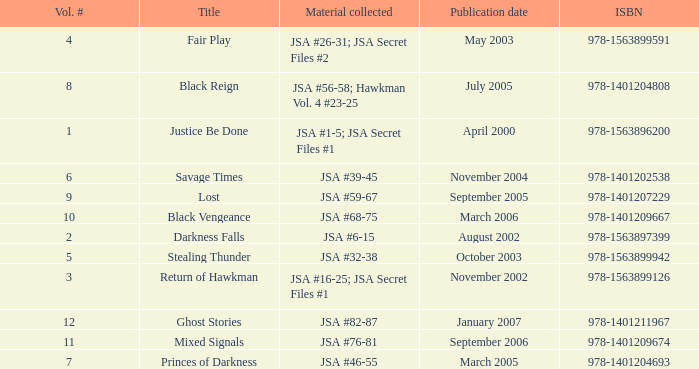How many Volume Numbers have the title of Darkness Falls? 2.0. 